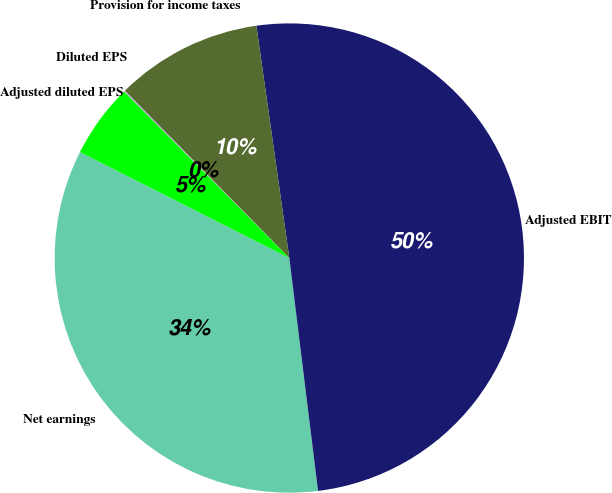Convert chart. <chart><loc_0><loc_0><loc_500><loc_500><pie_chart><fcel>Net earnings<fcel>Adjusted EBIT<fcel>Provision for income taxes<fcel>Diluted EPS<fcel>Adjusted diluted EPS<nl><fcel>34.41%<fcel>50.29%<fcel>10.12%<fcel>0.08%<fcel>5.1%<nl></chart> 